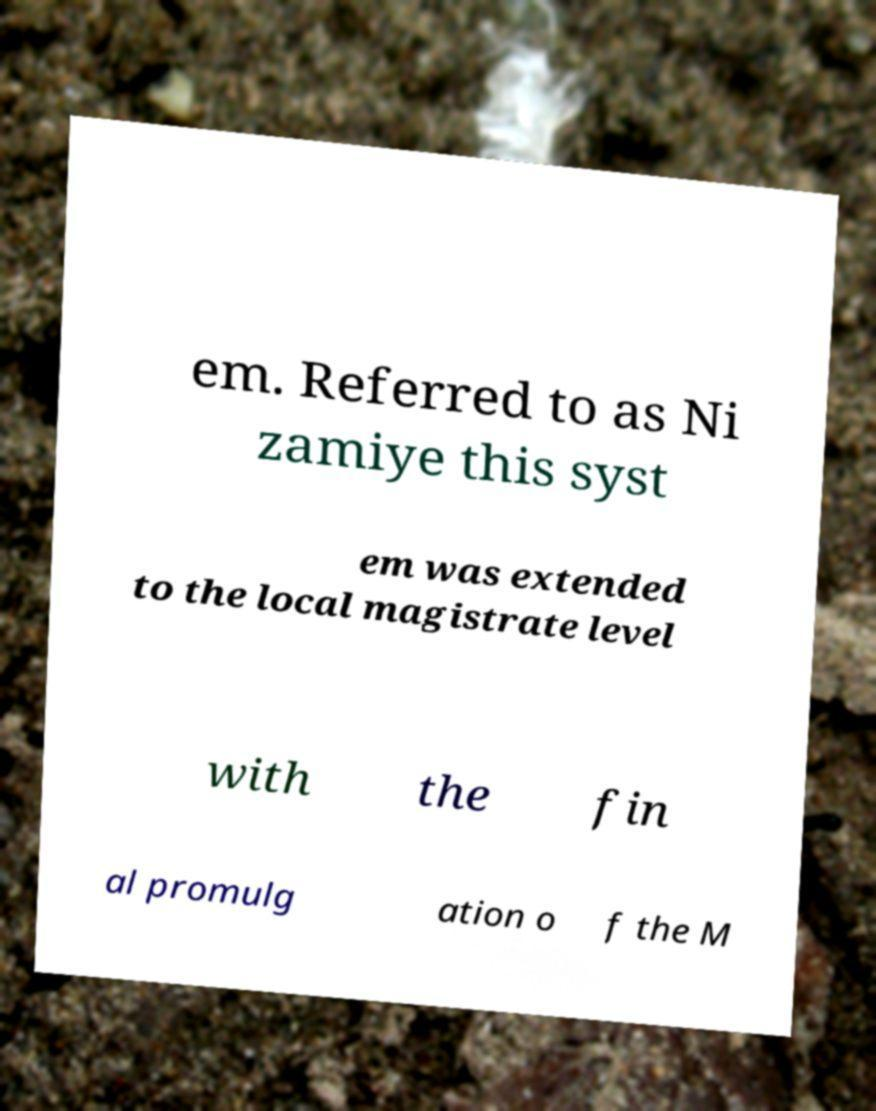I need the written content from this picture converted into text. Can you do that? em. Referred to as Ni zamiye this syst em was extended to the local magistrate level with the fin al promulg ation o f the M 